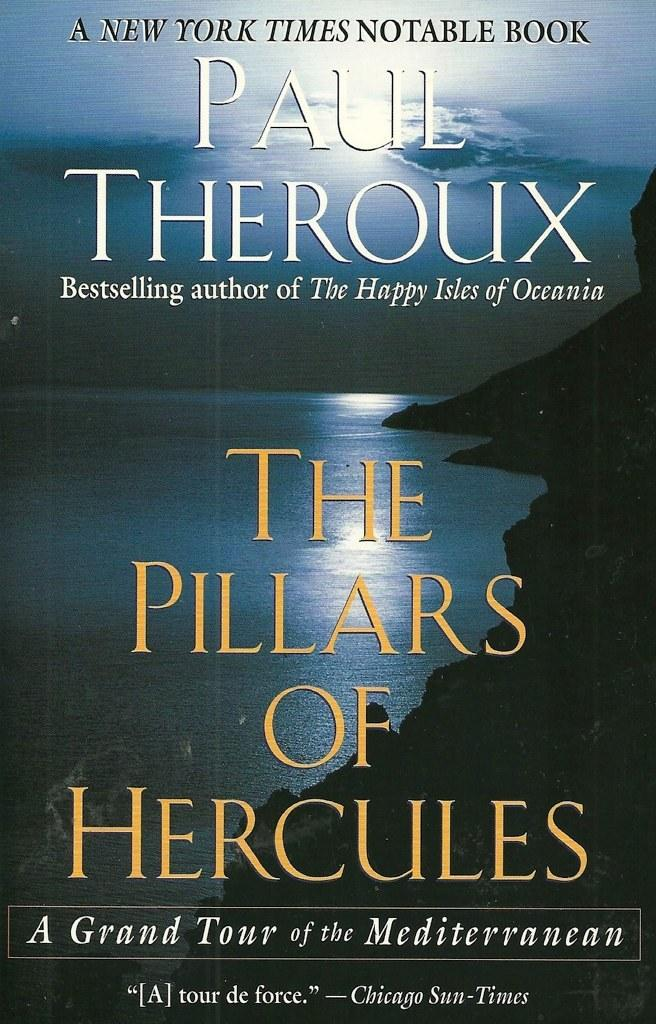<image>
Present a compact description of the photo's key features. A book with a picture of the sea titled "The Pillars of Hercules". 